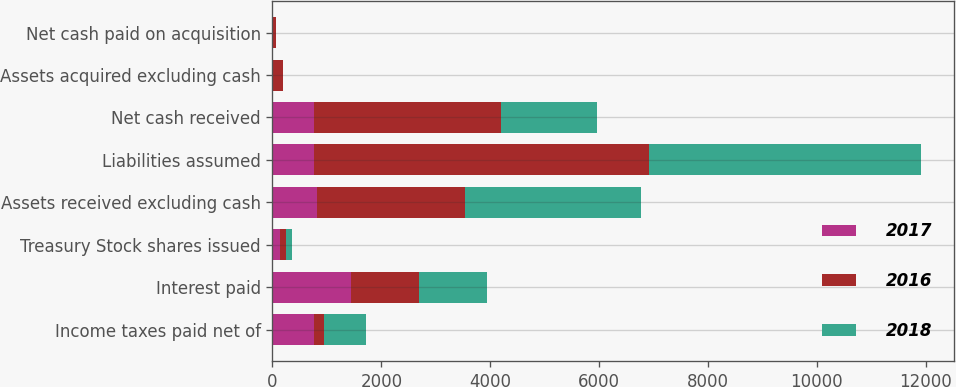<chart> <loc_0><loc_0><loc_500><loc_500><stacked_bar_chart><ecel><fcel>Income taxes paid net of<fcel>Interest paid<fcel>Treasury Stock shares issued<fcel>Assets received excluding cash<fcel>Liabilities assumed<fcel>Net cash received<fcel>Assets acquired excluding cash<fcel>Net cash paid on acquisition<nl><fcel>2017<fcel>760<fcel>1443<fcel>138<fcel>816<fcel>765<fcel>765<fcel>0<fcel>0<nl><fcel>2016<fcel>185<fcel>1248<fcel>104<fcel>2726<fcel>6155<fcel>3429<fcel>196<fcel>64<nl><fcel>2018<fcel>770<fcel>1257<fcel>115<fcel>3228<fcel>5003<fcel>1775<fcel>0<fcel>0<nl></chart> 